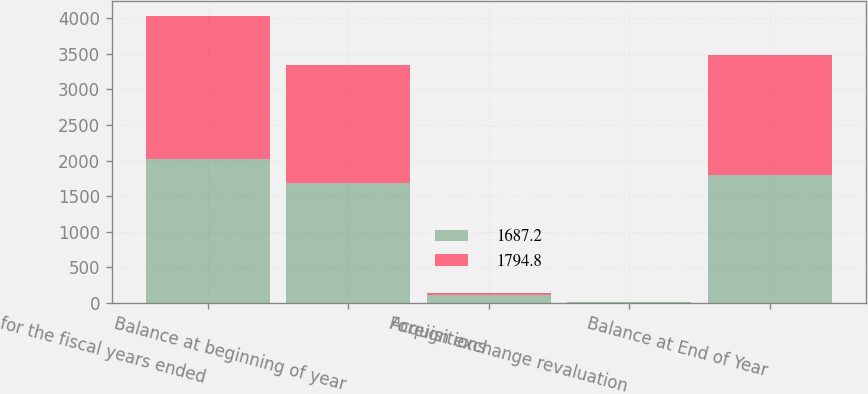<chart> <loc_0><loc_0><loc_500><loc_500><stacked_bar_chart><ecel><fcel>for the fiscal years ended<fcel>Balance at beginning of year<fcel>Acquisitions<fcel>Foreign exchange revaluation<fcel>Balance at End of Year<nl><fcel>1687.2<fcel>2018<fcel>1687.2<fcel>117.4<fcel>9.8<fcel>1794.8<nl><fcel>1794.8<fcel>2017<fcel>1661.2<fcel>18.8<fcel>7.2<fcel>1687.2<nl></chart> 